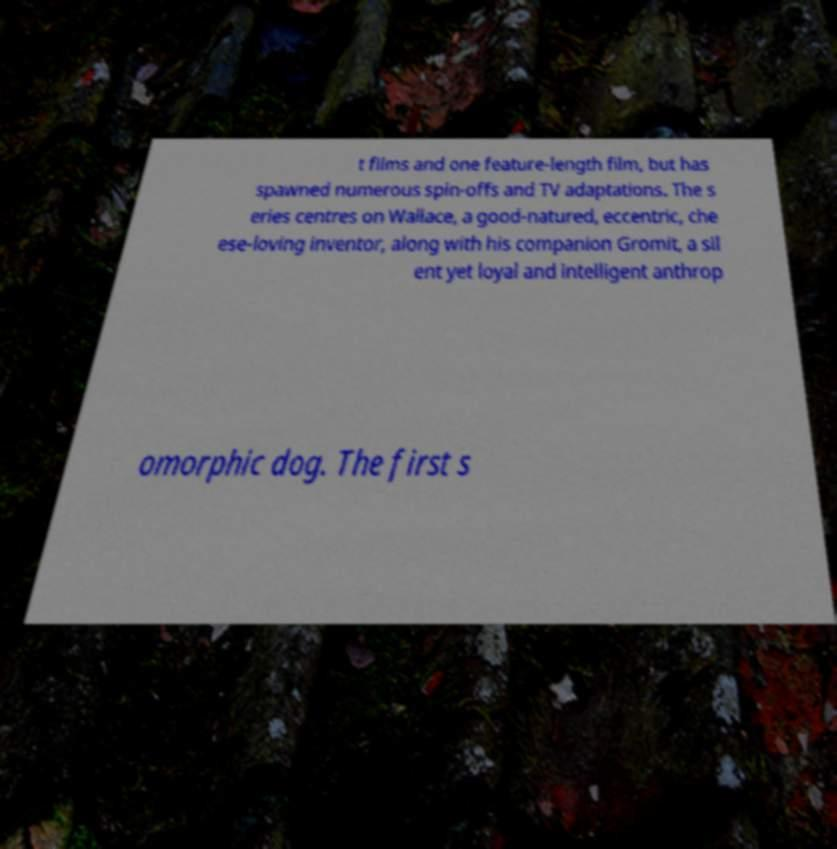Could you assist in decoding the text presented in this image and type it out clearly? t films and one feature-length film, but has spawned numerous spin-offs and TV adaptations. The s eries centres on Wallace, a good-natured, eccentric, che ese-loving inventor, along with his companion Gromit, a sil ent yet loyal and intelligent anthrop omorphic dog. The first s 